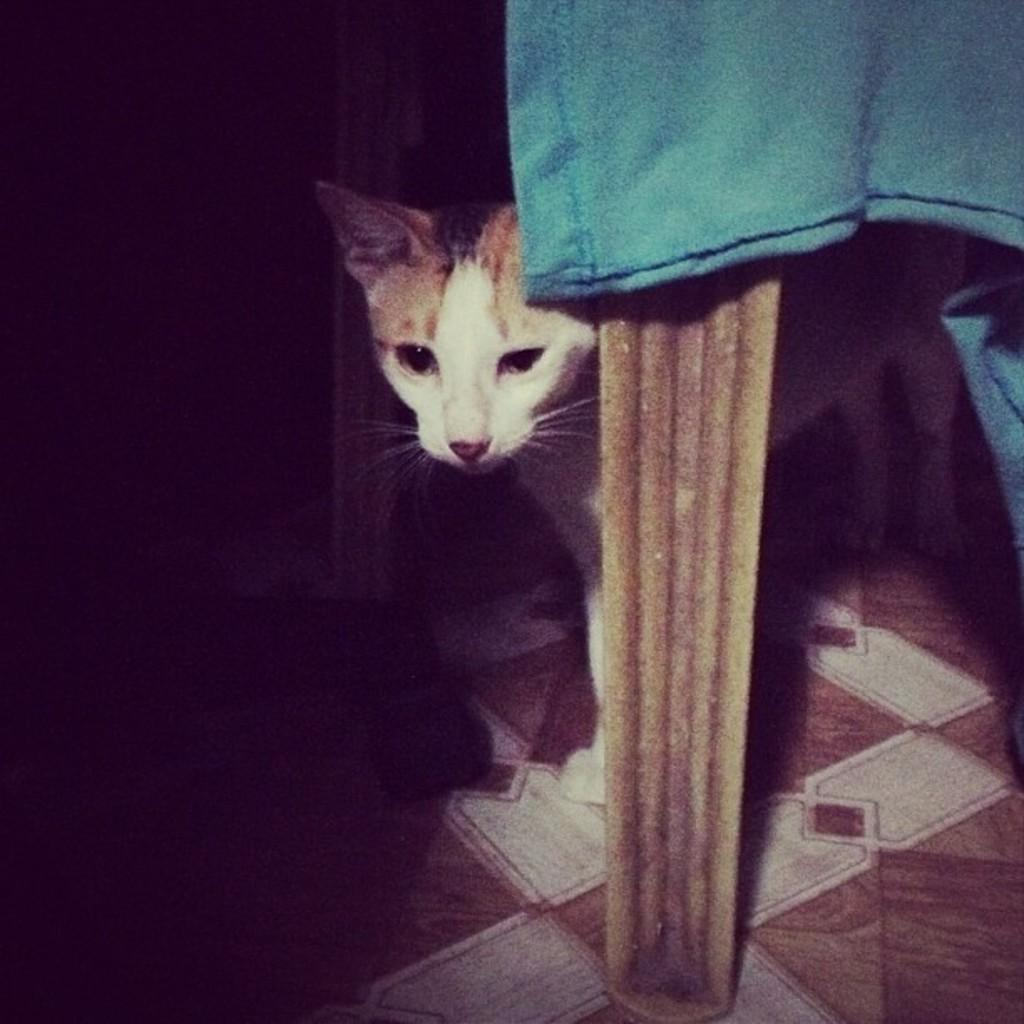What is the main subject in the center of the image? There is a cat in the center of the image. What type of furniture can be seen in the image? There is a chair in the image. What is draped or hanging at the top of the image? There is a cloth at the top of the image. What type of surface is visible at the bottom of the image? There is a floor visible at the bottom of the image. Can you see any farm animals through the window in the image? There is no window present in the image, so it is not possible to see any farm animals. 